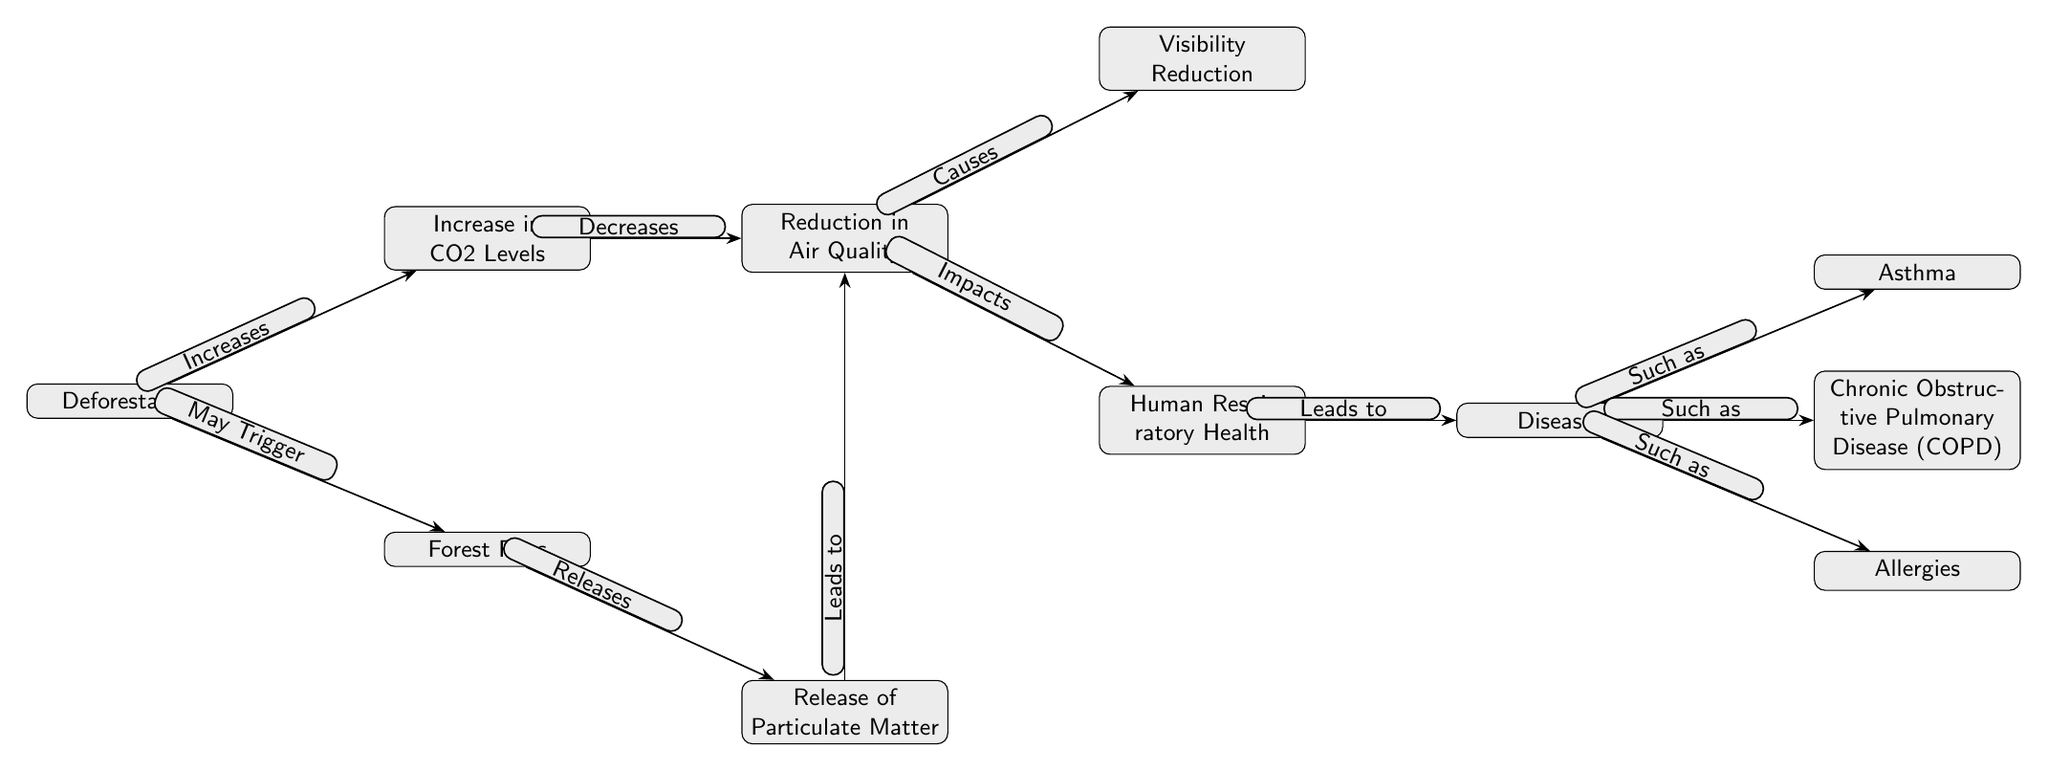What causes visibility reduction? The diagram indicates that visibility reduction is a consequence of the reduction in air quality, which is linked to several factors including particulate matter and CO2 levels. Thus, visibility reduction is directly caused by the reduction in air quality.
Answer: Reduction in air quality How many diseases are listed in the diagram? By inspecting the diagram, there are three specific diseases mentioned: asthma, chronic obstructive pulmonary disease (COPD), and allergies. Adding these up gives a total of three diseases listed.
Answer: 3 What triggers forest fires according to the diagram? The diagram suggests that deforestation may trigger forest fires, indicated by the phrase "May Trigger" that labels the connection from deforestation to forest fires.
Answer: Deforestation What does the release of particulate matter lead to? The diagram shows that the release of particulate matter leads to a reduction in air quality, which is indicated by the arrow labeled "Leads to" connecting particulate matter to air quality.
Answer: Reduction in air quality Which health condition is NOT mentioned in the diagram? The diagram specifically mentions asthma, COPD, and allergies as health conditions linked to human respiratory health. Any conditions not listed here, such as lung cancer or pneumonia, would not be mentioned in the diagram.
Answer: Lung cancer (or any other not listed condition) What effect does the increase in CO2 levels have? According to the diagram, the increase in CO2 levels leads to a decrease in air quality, as shown by the labeled connection between the increase in CO2 and the reduction in air quality.
Answer: Decreases air quality Which node represents the overall health impact of air quality changes? The node that represents the overall health impact due to changes in air quality is "Human Respiratory Health," which is the direct outcome of the reduction in air quality as per the diagram.
Answer: Human Respiratory Health How many edges connect to the diseases node? The diseases node is connected to three edges that lead to specific diseases: asthma, chronic obstructive pulmonary disease (COPD), and allergies. Therefore, the count of edges connected to the diseases node is three.
Answer: 3 